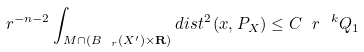<formula> <loc_0><loc_0><loc_500><loc_500>\ r ^ { - n - 2 } \int _ { M \cap ( B _ { \ r } ( X ^ { \prime } ) \times { \mathbf R } ) } d i s t ^ { 2 } \, ( x , P _ { X } ) \leq C \ r ^ { \ k } Q _ { 1 }</formula> 